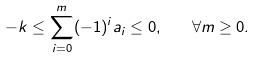<formula> <loc_0><loc_0><loc_500><loc_500>- k \leq \sum _ { i = 0 } ^ { m } ( - 1 ) ^ { i } a _ { i } \leq 0 , \quad \forall m \geq 0 .</formula> 